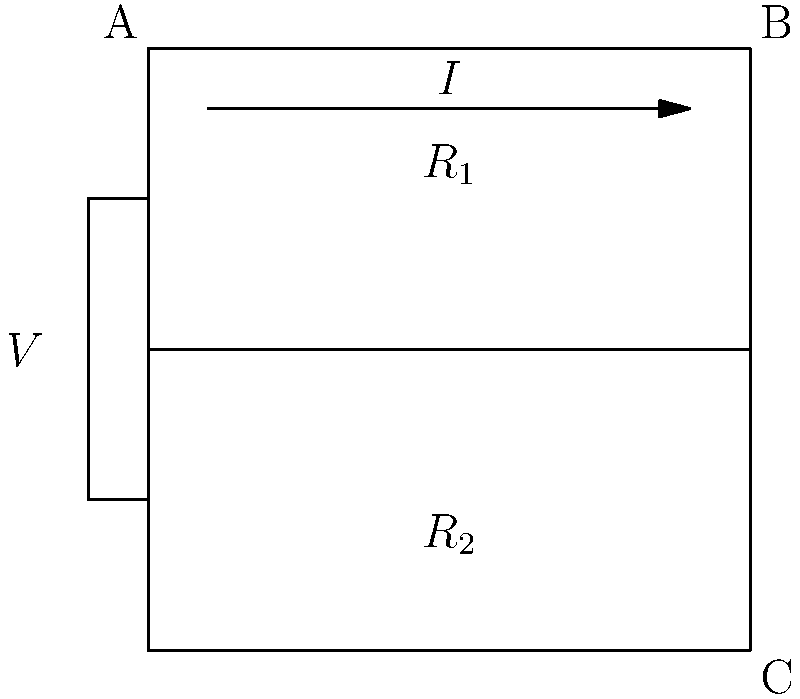In an enchanted armor design, magical energy flows through a circuit represented by the diagram above. The armor's chest plate ($R_1$) has a resistance of 6 ohms, while the back plate ($R_2$) has a resistance of 3 ohms. If the magical power source ($V$) provides 18 volts, what is the total current ($I$) flowing through the armor's circuit? To solve this problem, we'll use Ohm's Law and the principles of parallel circuits. Let's break it down step-by-step:

1) First, we need to calculate the total resistance of the circuit. Since $R_1$ and $R_2$ are in parallel, we use the formula for parallel resistors:

   $$\frac{1}{R_{total}} = \frac{1}{R_1} + \frac{1}{R_2}$$

2) Substituting the values:

   $$\frac{1}{R_{total}} = \frac{1}{6} + \frac{1}{3} = \frac{1}{6} + \frac{2}{6} = \frac{3}{6} = \frac{1}{2}$$

3) Therefore:

   $$R_{total} = 2 \text{ ohms}$$

4) Now that we have the total resistance, we can use Ohm's Law to calculate the current. Ohm's Law states that:

   $$I = \frac{V}{R}$$

   Where $I$ is the current, $V$ is the voltage, and $R$ is the resistance.

5) Substituting our values:

   $$I = \frac{18 \text{ volts}}{2 \text{ ohms}} = 9 \text{ amperes}$$

Thus, the total current flowing through the armor's circuit is 9 amperes.
Answer: 9 amperes 